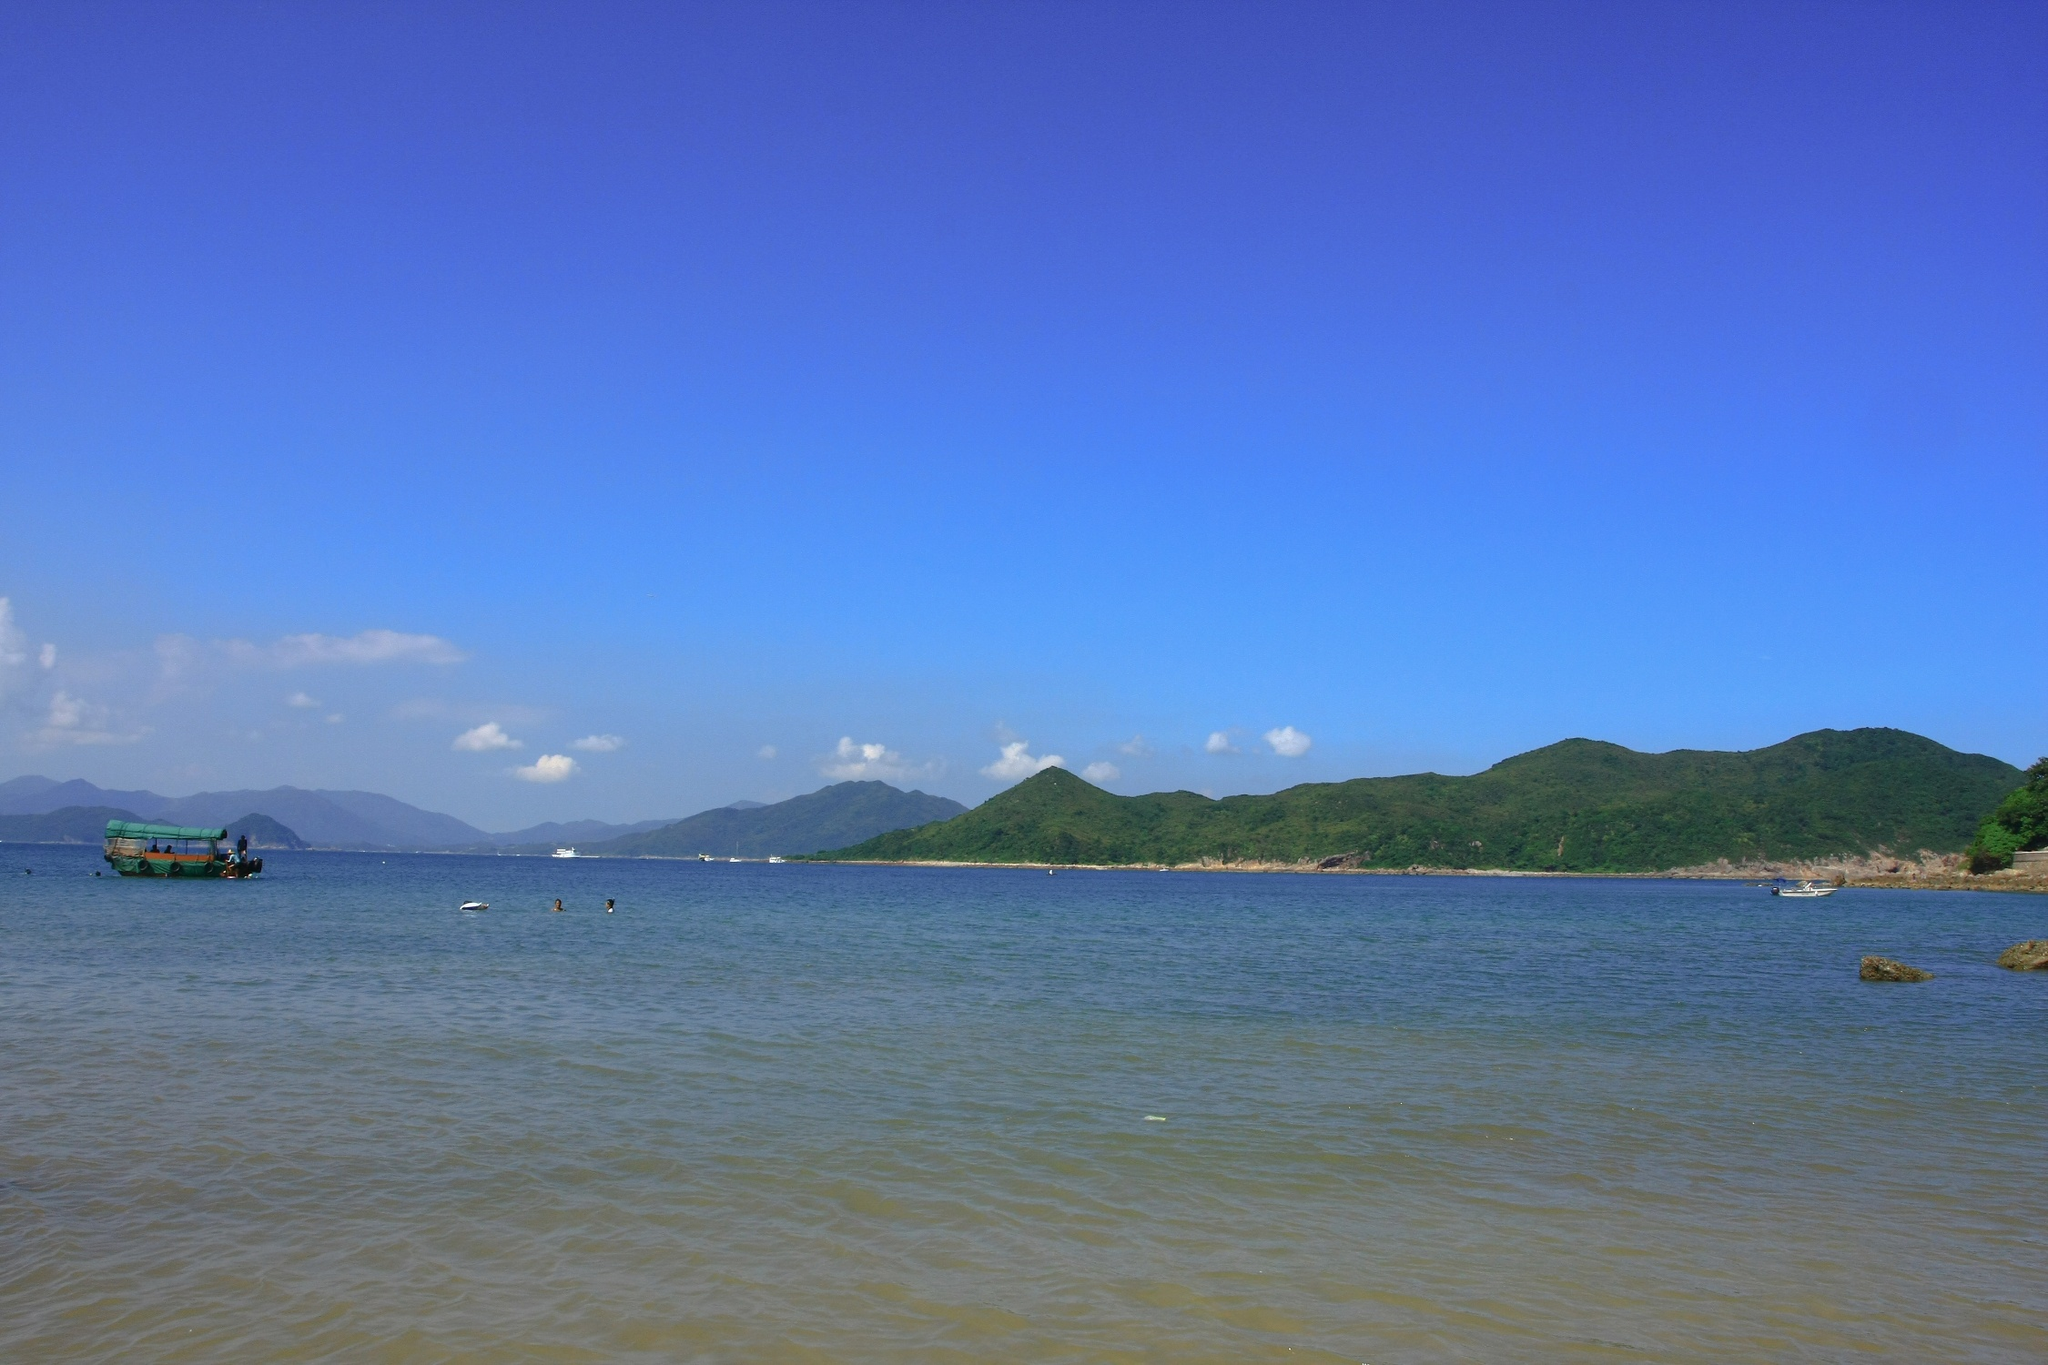Describe the feelings this image evokes. The image evokes a profound sense of calm and tranquility. The serene waters, coupled with the clear, expansive sky, create a peaceful and meditative atmosphere. The isolated green boat hints at solitude, suggesting a moment of personal reflection or quiet escape away from the hustle and bustle of daily life. Overall, the photograph inspires feelings of relaxation, peace, and a deep connection with nature. What time of day do you think it is in the image? Based on the bright and ample light in the image, it appears to be taken during the mid-morning to early afternoon. The lighting is strong and evenly distributed, indicating the sun is relatively high in the sky, which is common during this time of day. Can you create a story about the person on the green boat? Certainly! The person on the green boat is an elderly fisherman named Tomas who has been fishing these waters for decades. Every morning, Tomas sets out before sunrise to catch the freshest fish. Today, however, he decided to take a break from his routine to simply enjoy the beauty of the sea. As he drifts silently on the calm water, he reflects on his life - the days spent out at sea, the storms weathered, and the simple joys of a hard but fulfilling life. The sea has always been like a second home to him, a place where he finds peace and solace. The distant mountains remind him of his childhood, where he used to hike with his friends, and now, in his older years, these moments at sea offer him a quiet contentment few can understand. 